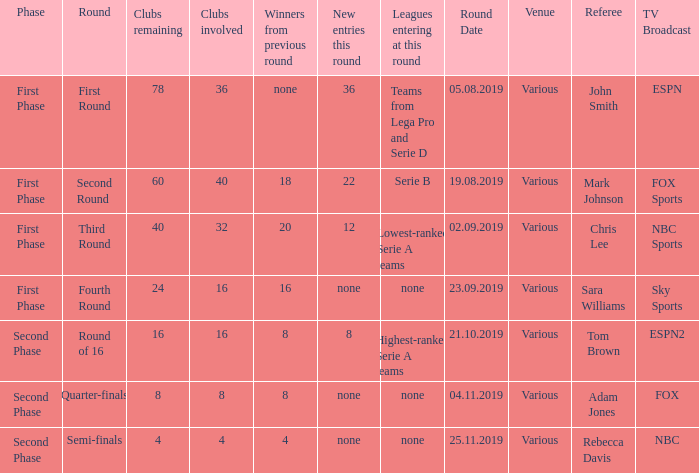From the round name of third round; what would the new entries this round that would be found? 12.0. 